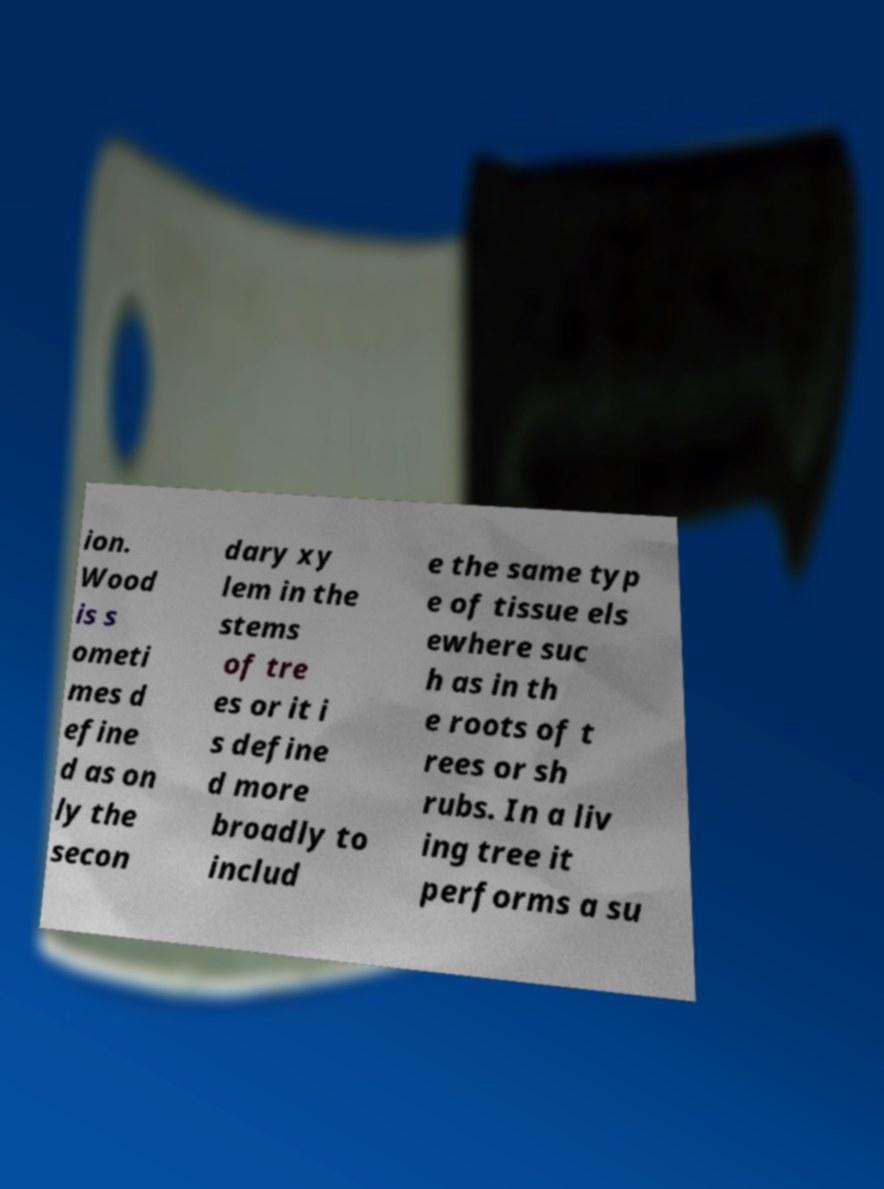Please read and relay the text visible in this image. What does it say? ion. Wood is s ometi mes d efine d as on ly the secon dary xy lem in the stems of tre es or it i s define d more broadly to includ e the same typ e of tissue els ewhere suc h as in th e roots of t rees or sh rubs. In a liv ing tree it performs a su 